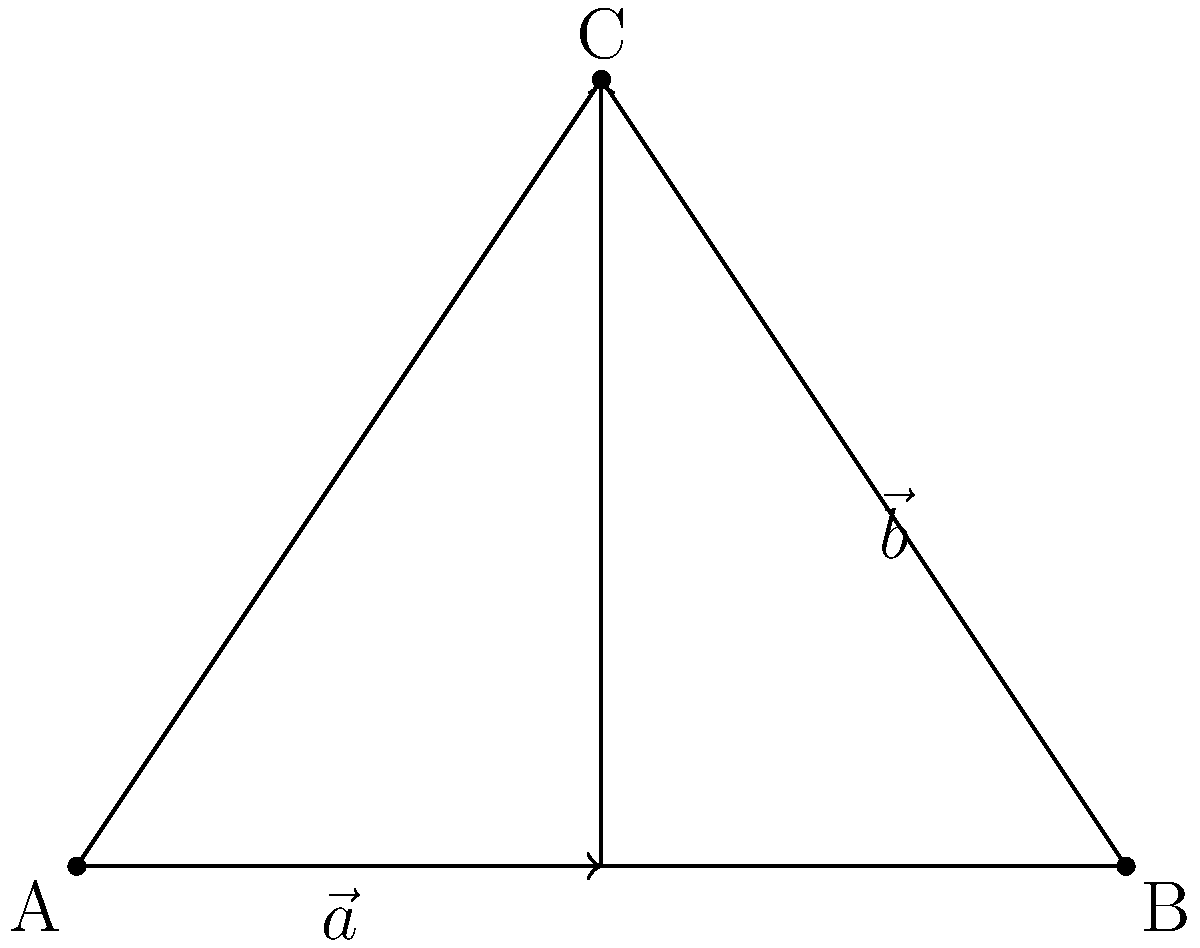In a popular reality TV show set, three cameras are positioned at points A, B, and C forming a triangle. The vector from A to C can be expressed as the sum of two vectors, $\vec{a}$ and $\vec{b}$. If $\vec{a} = 2\hat{i}$ and $\vec{b} = 2\hat{i} + 3\hat{j}$, what is the magnitude of the vector from A to C? Let's solve this step-by-step:

1) The vector from A to C is the sum of $\vec{a}$ and $\vec{b}$. Let's call this vector $\vec{AC}$.

   $\vec{AC} = \vec{a} + \vec{b}$

2) We're given that $\vec{a} = 2\hat{i}$ and $\vec{b} = 2\hat{i} + 3\hat{j}$

3) Let's substitute these into our equation:

   $\vec{AC} = 2\hat{i} + (2\hat{i} + 3\hat{j})$

4) Simplify by combining like terms:

   $\vec{AC} = 4\hat{i} + 3\hat{j}$

5) To find the magnitude of $\vec{AC}$, we use the Pythagorean theorem:

   $|\vec{AC}| = \sqrt{(4)^2 + (3)^2}$

6) Simplify:

   $|\vec{AC}| = \sqrt{16 + 9} = \sqrt{25} = 5$

Therefore, the magnitude of the vector from A to C is 5 units.
Answer: 5 units 